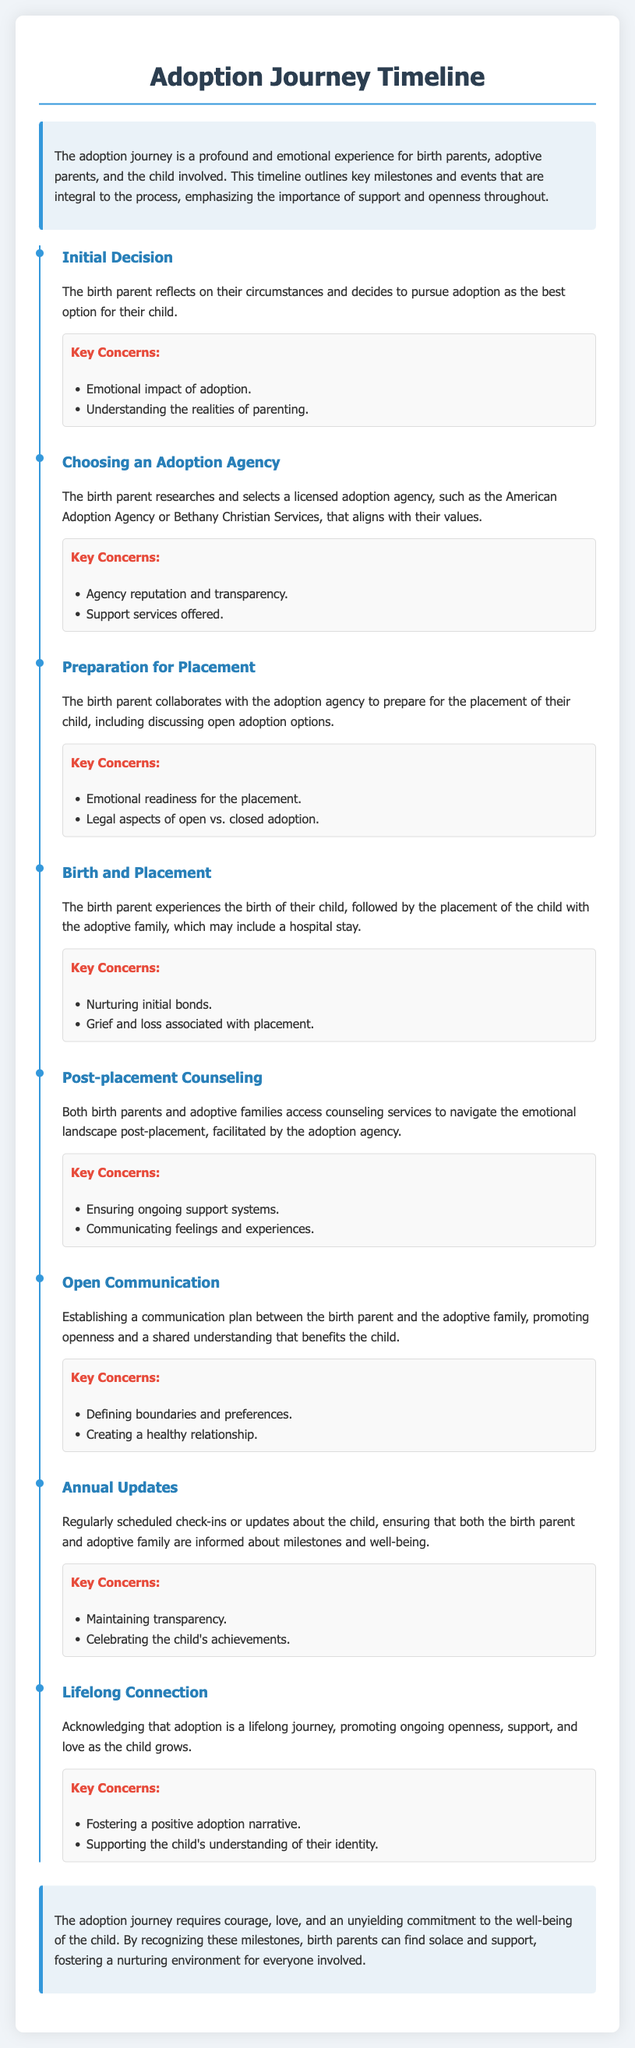what is the first milestone in the adoption journey? The first milestone in the timeline is the decision made by the birth parent to pursue adoption as the best option for their child.
Answer: Initial Decision what is the purpose of choosing an adoption agency? The birth parent selects an adoption agency that aligns with their values and supports them throughout the process.
Answer: Agency reputation and transparency what is one key concern during the Birth and Placement event? This concern reflects the emotional experience for the birth parent, particularly in relation to the placement of their child.
Answer: Grief and loss associated with placement who provides the post-placement counseling services? The counseling services are facilitated by the adoption agency for both birth parents and adoptive families.
Answer: Adoption agency what is a significant aspect of the Open Communication phase? Establishing a communication plan is crucial for fostering a healthy relationship between the birth parent and adoptive family.
Answer: Defining boundaries and preferences how many key concerns are listed for the Lifelong Connection milestone? This milestone includes two key concerns regarding the adoption journey as a lifelong process.
Answer: Two what does the document emphasize regarding the adoption journey? The document highlights the importance of support and openness for all parties involved in the adoption process.
Answer: Support and openness what is the overall theme presented in the conclusion of the document? The conclusion emphasizes the emotional commitment required in the adoption journey and the importance of nurturing relationships.
Answer: Courage, love, and commitment 